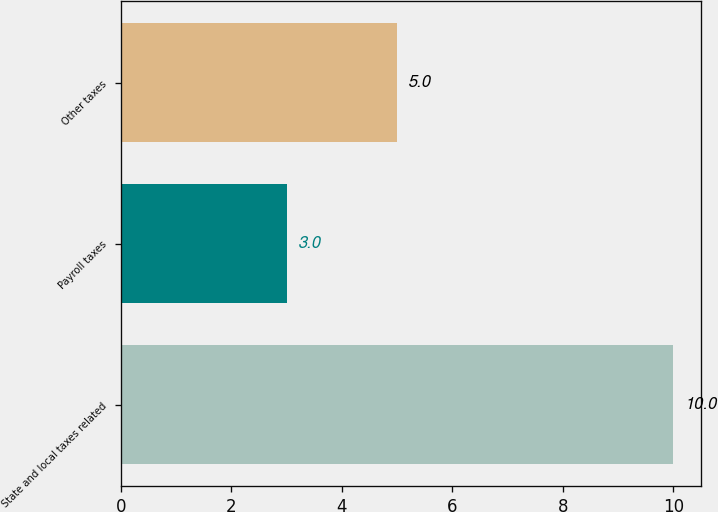Convert chart to OTSL. <chart><loc_0><loc_0><loc_500><loc_500><bar_chart><fcel>State and local taxes related<fcel>Payroll taxes<fcel>Other taxes<nl><fcel>10<fcel>3<fcel>5<nl></chart> 